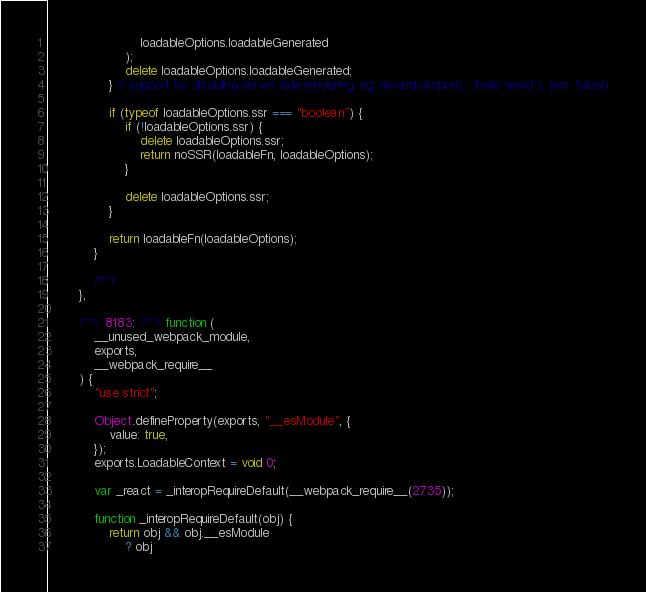<code> <loc_0><loc_0><loc_500><loc_500><_JavaScript_>                        loadableOptions.loadableGenerated
                    );
                    delete loadableOptions.loadableGenerated;
                } // support for disabling server side rendering, eg: dynamic(import('../hello-world'), {ssr: false})

                if (typeof loadableOptions.ssr === "boolean") {
                    if (!loadableOptions.ssr) {
                        delete loadableOptions.ssr;
                        return noSSR(loadableFn, loadableOptions);
                    }

                    delete loadableOptions.ssr;
                }

                return loadableFn(loadableOptions);
            }

            /***/
        },

        /***/ 8183: /***/ function (
            __unused_webpack_module,
            exports,
            __webpack_require__
        ) {
            "use strict";

            Object.defineProperty(exports, "__esModule", {
                value: true,
            });
            exports.LoadableContext = void 0;

            var _react = _interopRequireDefault(__webpack_require__(2735));

            function _interopRequireDefault(obj) {
                return obj && obj.__esModule
                    ? obj</code> 